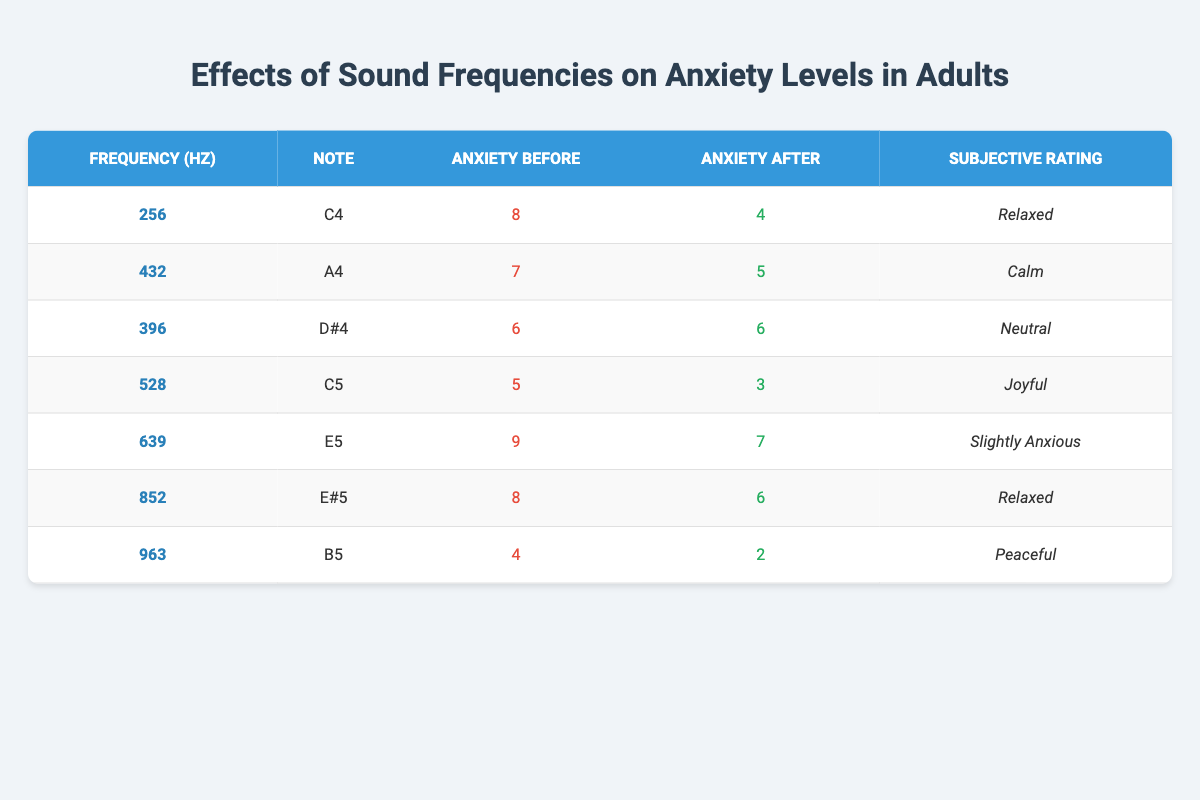What is the subjective rating associated with the frequency of 528 Hz? To find the subjective rating for 528 Hz, I look for the entry in the table where the frequency is listed as 528. The subjective rating for that row is "Joyful."
Answer: Joyful What was the anxiety level before exposure to the sound frequency 639 Hz? In the row for the frequency of 639 Hz, the anxiety level before exposure is listed as 9.
Answer: 9 Which frequency showed the largest decrease in anxiety levels after exposure? To determine the largest decrease, I need to calculate the difference between the anxiety levels before and after for each frequency. The changes are: 8-4=4 for 256 Hz, 7-5=2 for 432 Hz, 6-6=0 for 396 Hz, 5-3=2 for 528 Hz, 9-7=2 for 639 Hz, 8-6=2 for 852 Hz, and 4-2=2 for 963 Hz. The largest decrease is 4 for the frequency of 256 Hz.
Answer: 256 Hz What is the average anxiety level after exposure to all sound frequencies? I calculate the average by summing the anxiety levels after all exposures (4 + 5 + 6 + 3 + 7 + 6 + 2 = 33) and then dividing by the number of frequencies, which is 7. The average is 33 / 7 = 4.71, approximately 4.71.
Answer: 4.71 Is it true that the subjective rating for the frequency of 396 Hz is "Calm"? I check the table for the entry corresponding to 396 Hz. The subjective rating listed is "Neutral," not "Calm." Thus, the statement is false.
Answer: No Which frequency had the lowest anxiety level after exposure, and what was that level? I look for the row with the lowest value in the "Anxiety After" column. The values are 4, 5, 6, 3, 7, 6, and 2. The lowest value is 2 for the frequency of 963 Hz.
Answer: 963 Hz, 2 After listening to the frequency of 852 Hz, how much did the anxiety level decrease? I first find the anxiety level before and after exposure to the frequency of 852 Hz, which are 8 and 6, respectively. The decrease is calculated as 8 - 6 = 2.
Answer: 2 